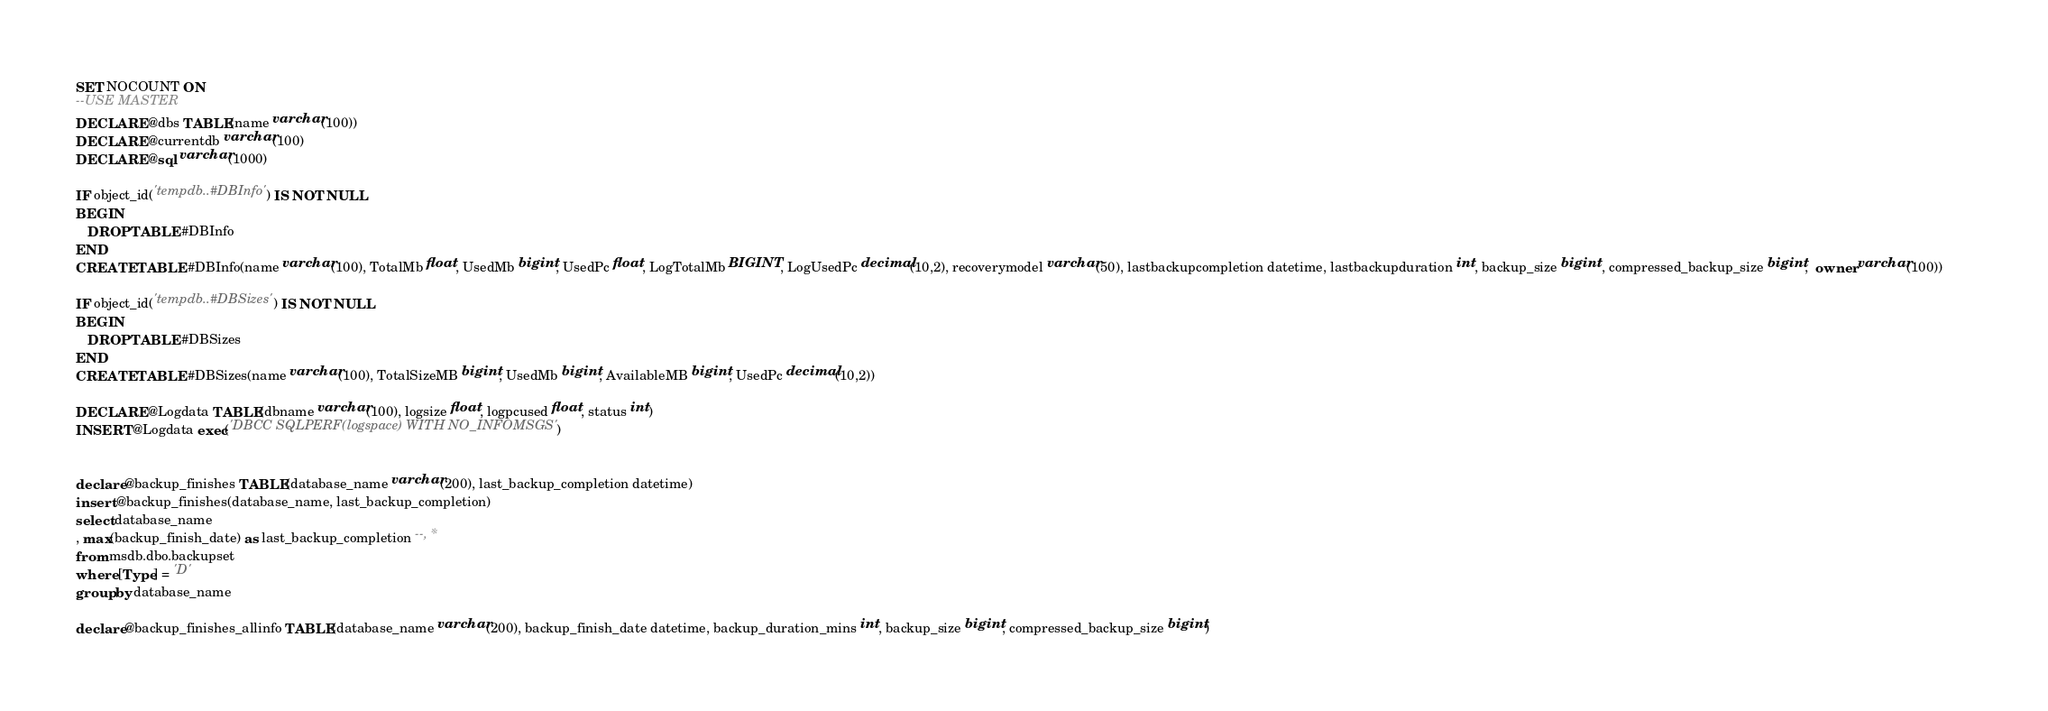<code> <loc_0><loc_0><loc_500><loc_500><_SQL_>SET NOCOUNT ON
--USE MASTER
DECLARE @dbs TABLE(name varchar(100))
DECLARE @currentdb varchar(100)
DECLARE @sql varchar(1000)

IF object_id('tempdb..#DBInfo') IS NOT NULL
BEGIN
   DROP TABLE #DBInfo
END	
CREATE TABLE #DBInfo(name varchar(100), TotalMb float, UsedMb bigint, UsedPc float, LogTotalMb BIGINT, LogUsedPc decimal(10,2), recoverymodel varchar(50), lastbackupcompletion datetime, lastbackupduration int, backup_size bigint , compressed_backup_size bigint,  owner varchar(100))		

IF object_id('tempdb..#DBSizes') IS NOT NULL
BEGIN
   DROP TABLE #DBSizes
END	
CREATE TABLE #DBSizes(name varchar(100), TotalSizeMB bigint, UsedMb bigint, AvailableMB bigint, UsedPc decimal(10,2))

DECLARE @Logdata TABLE(dbname varchar(100), logsize float, logpcused float, status int)
INSERT @Logdata exec('DBCC SQLPERF(logspace) WITH NO_INFOMSGS')


declare @backup_finishes TABLE(database_name varchar(200), last_backup_completion datetime)
insert @backup_finishes(database_name, last_backup_completion)
select database_name
, max(backup_finish_date) as last_backup_completion --, *
from msdb.dbo.backupset
where [Type] = 'D'
group by database_name

declare @backup_finishes_allinfo TABLE(database_name varchar(200), backup_finish_date datetime, backup_duration_mins int, backup_size bigint, compressed_backup_size bigint)</code> 